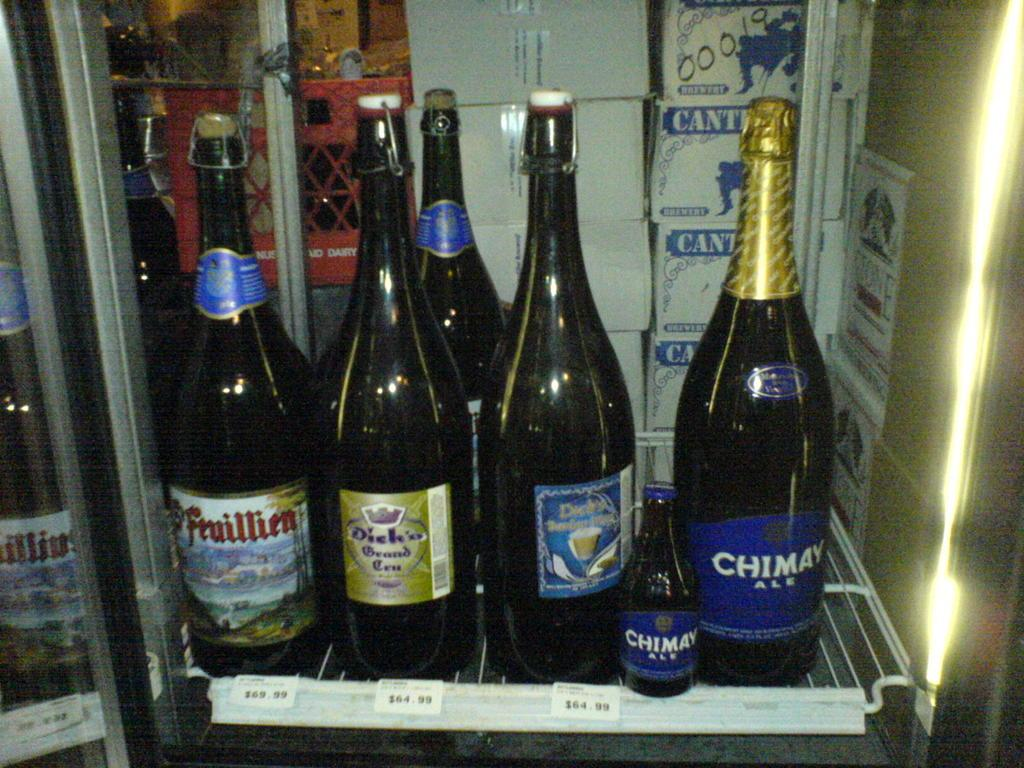<image>
Describe the image concisely. Bottle with a blue label that says CHIMAY on it. 